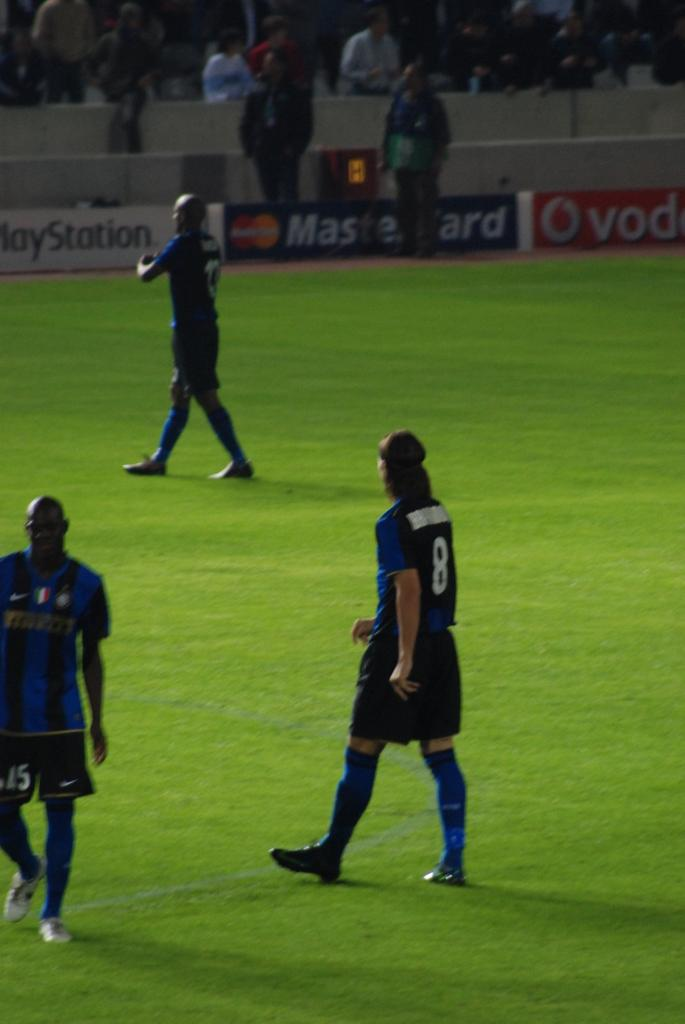<image>
Create a compact narrative representing the image presented. the back wall of a soccer field with a mastercard logo on it. 